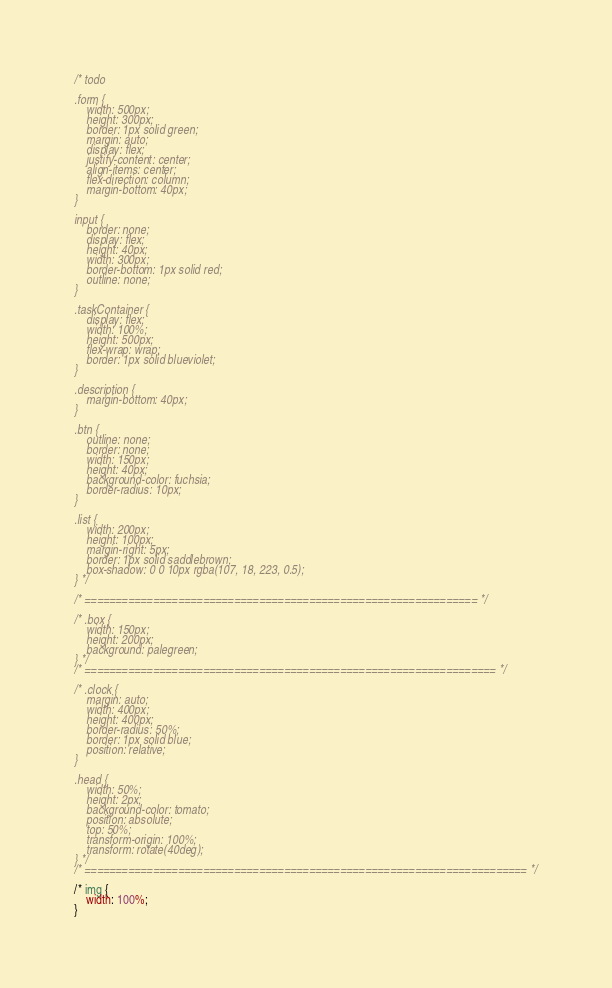<code> <loc_0><loc_0><loc_500><loc_500><_CSS_>/* todo

.form {
    width: 500px;
    height: 300px;
    border: 1px solid green;
    margin: auto;
    display: flex;
    justify-content: center;
    align-items: center;
    flex-direction: column;
    margin-bottom: 40px;
}

input {
    border: none;
    display: flex;
    height: 40px;
    width: 300px;
    border-bottom: 1px solid red;
    outline: none;
}

.taskContainer {
    display: flex;
    width: 100%;
    height: 500px;
    flex-wrap: wrap;
    border: 1px solid blueviolet; 
}

.description {
    margin-bottom: 40px;
}

.btn {
    outline: none;
    border: none;
    width: 150px;
    height: 40px;
    background-color: fuchsia;
    border-radius: 10px;
}

.list {
    width: 200px;
    height: 100px;
    margin-right: 5px;
    border: 1px solid saddlebrown;
    box-shadow: 0 0 10px rgba(107, 18, 223, 0.5);
} */

/* =============================================================== */

/* .box {
    width: 150px;
    height: 200px;
    background: palegreen;
} */
/* ================================================================== */

/* .clock {
    margin: auto;
    width: 400px;
    height: 400px;
    border-radius: 50%;
    border: 1px solid blue;
    position: relative;
}

.head {
    width: 50%;
    height: 2px;
    background-color: tomato;
    position: absolute;
    top: 50%;
    transform-origin: 100%;
    transform: rotate(40deg);
} */
/* ======================================================================= */

/* img {
    width: 100%;
}
</code> 